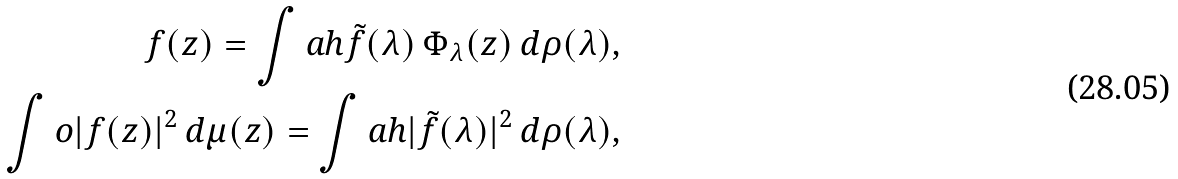Convert formula to latex. <formula><loc_0><loc_0><loc_500><loc_500>f ( z ) = \int a h \tilde { f } ( \lambda ) \, \Phi _ { \lambda } ( z ) \, d \rho ( \lambda ) , \\ \int o | f ( z ) | ^ { 2 } \, d \mu ( z ) = \int a h | \tilde { f } ( \lambda ) | ^ { 2 } \, d \rho ( \lambda ) ,</formula> 